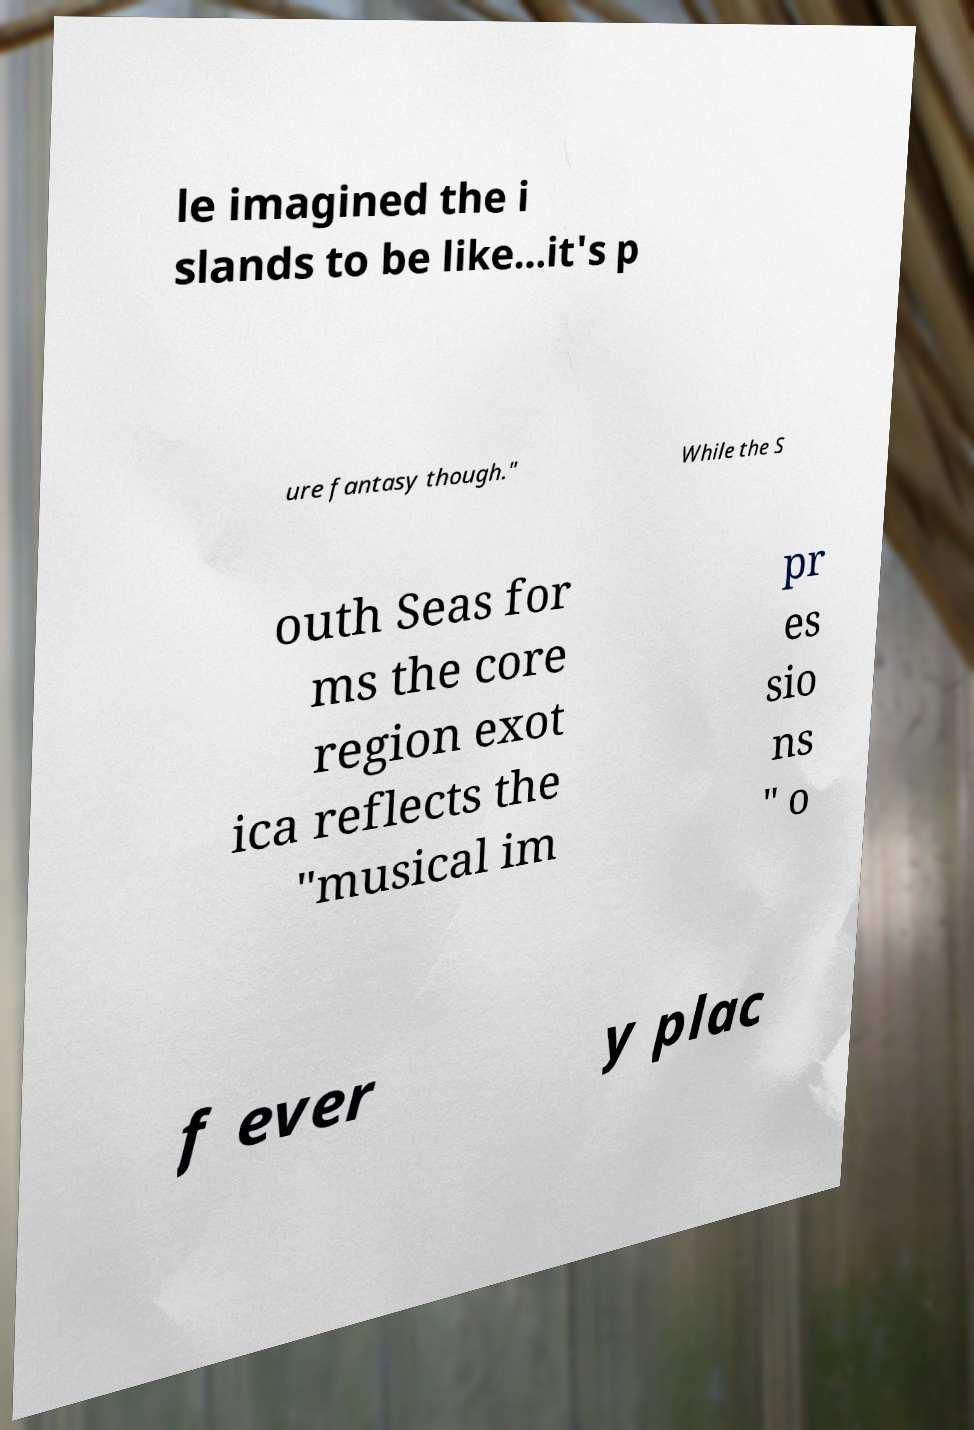I need the written content from this picture converted into text. Can you do that? le imagined the i slands to be like...it's p ure fantasy though." While the S outh Seas for ms the core region exot ica reflects the "musical im pr es sio ns " o f ever y plac 